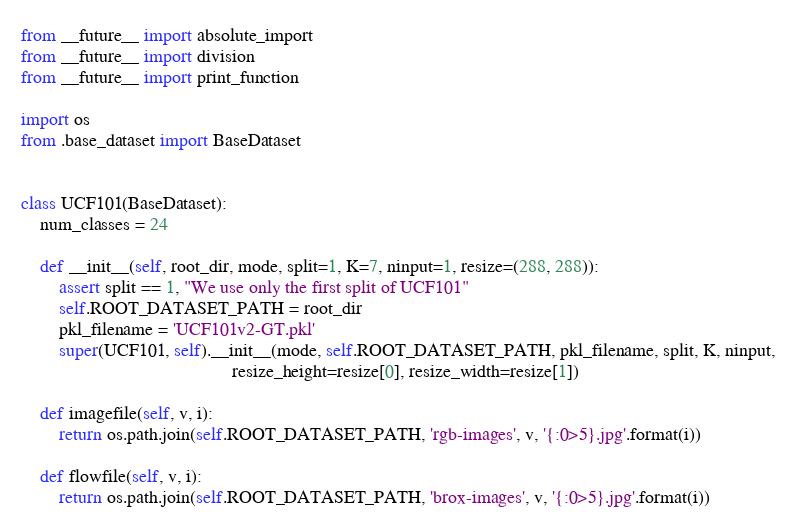<code> <loc_0><loc_0><loc_500><loc_500><_Python_>from __future__ import absolute_import
from __future__ import division
from __future__ import print_function

import os
from .base_dataset import BaseDataset


class UCF101(BaseDataset):
    num_classes = 24

    def __init__(self, root_dir, mode, split=1, K=7, ninput=1, resize=(288, 288)):
        assert split == 1, "We use only the first split of UCF101"
        self.ROOT_DATASET_PATH = root_dir
        pkl_filename = 'UCF101v2-GT.pkl'
        super(UCF101, self).__init__(mode, self.ROOT_DATASET_PATH, pkl_filename, split, K, ninput,
                                             resize_height=resize[0], resize_width=resize[1])

    def imagefile(self, v, i):
        return os.path.join(self.ROOT_DATASET_PATH, 'rgb-images', v, '{:0>5}.jpg'.format(i))

    def flowfile(self, v, i):
        return os.path.join(self.ROOT_DATASET_PATH, 'brox-images', v, '{:0>5}.jpg'.format(i))
</code> 